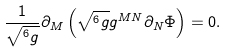Convert formula to latex. <formula><loc_0><loc_0><loc_500><loc_500>\frac { 1 } { { \sqrt { ^ { 6 } g } } } \partial _ { M } \left ( { \sqrt { ^ { 6 } g } g ^ { M N } \partial _ { N } \Phi } \right ) = 0 .</formula> 